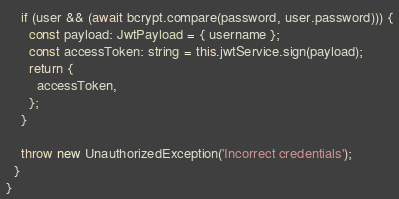<code> <loc_0><loc_0><loc_500><loc_500><_TypeScript_>    if (user && (await bcrypt.compare(password, user.password))) {
      const payload: JwtPayload = { username };
      const accessToken: string = this.jwtService.sign(payload);
      return {
        accessToken,
      };
    }

    throw new UnauthorizedException('Incorrect credentials');
  }
}
</code> 